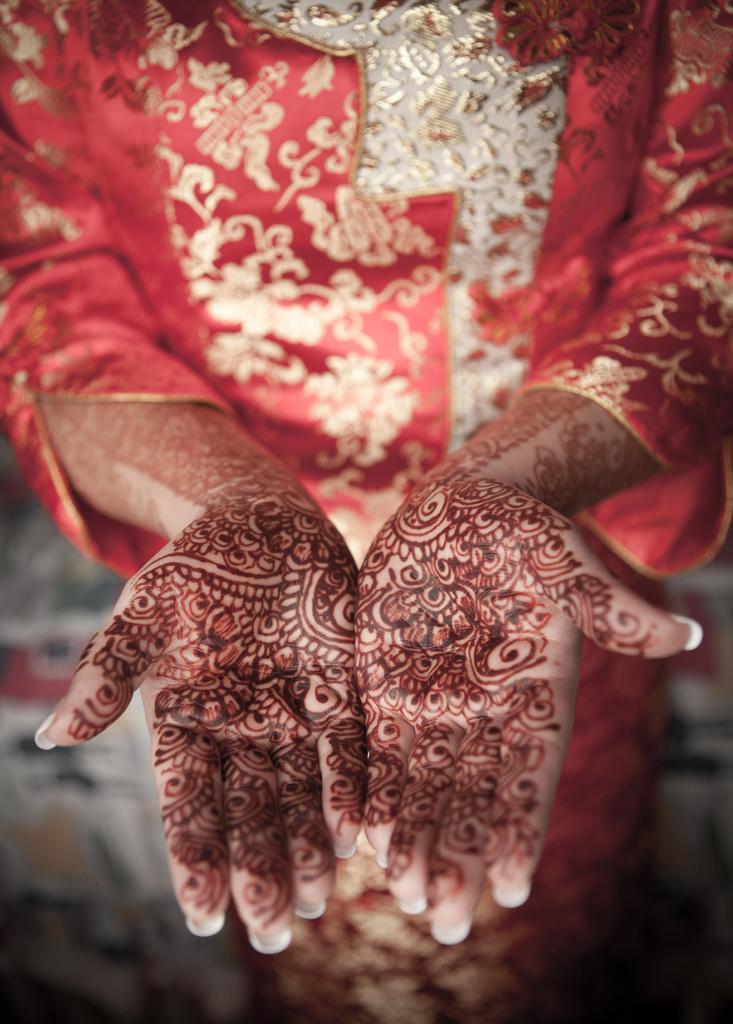How would you summarize this image in a sentence or two? In this image I can see the person and the person is wearing red and gold color dress. 